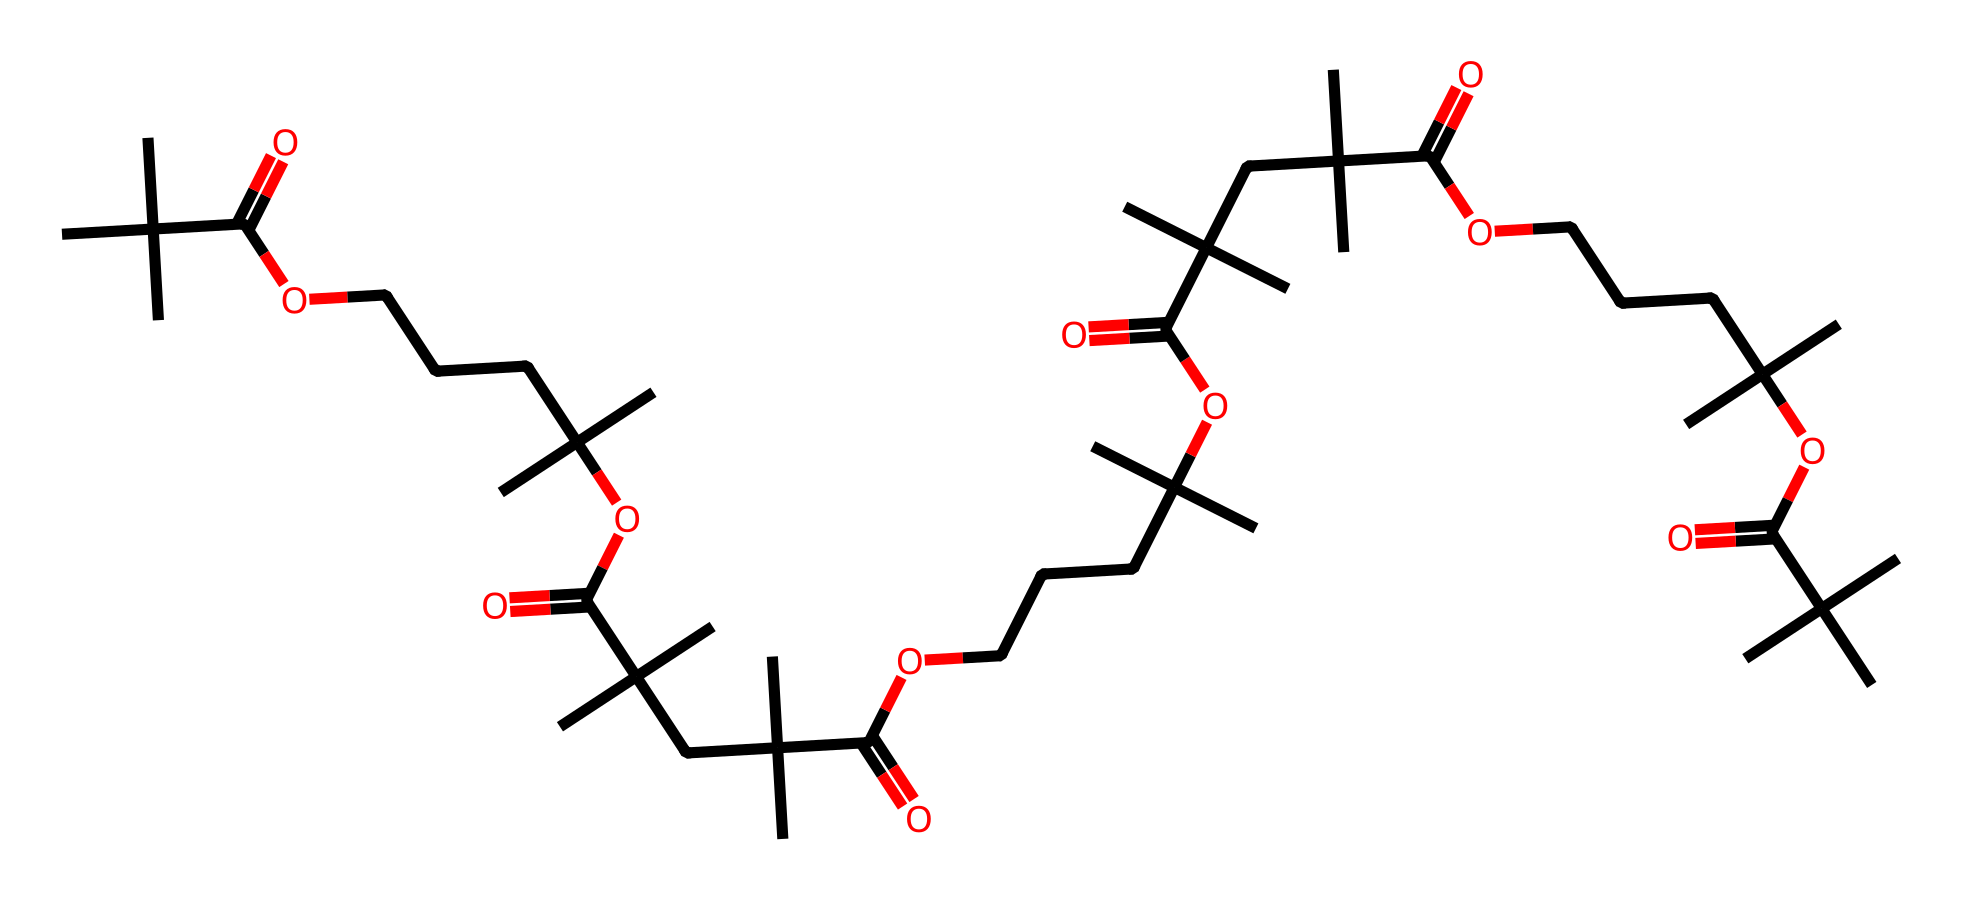What is the main functional group present in this polymer? The polymer contains multiple carboxylic acid groups, identified by the presence of the -C(=O)O structure within the SMILES representation.
Answer: carboxylic acid How many repeating units are in the polymer chain? By analyzing the repeating pattern in the SMILES representation, we see that there are several segments that repeat, indicating multiple units present in the structure. Counting them, we find nine repeating units.
Answer: nine What type of polymer is represented by this structure? The presence of ester linkages (OCC) and the structure suggests that it is a polyester-type polymer, as they are formed through condensation reactions between carboxylic acids and alcohols.
Answer: polyester What is the total number of carbon atoms in the structure? By examining the SMILES and counting the carbon atoms, we find the total number of carbon atoms represented in the structure is 40.
Answer: 40 What property does the arrangement of this polymer impart that aids in self-healing? The molecular arrangement of the flexible chains and functional groups allows for dynamic interactions and reformation of the bonds, enabling the polymer to flow and heal itself when damaged.
Answer: flexibility 